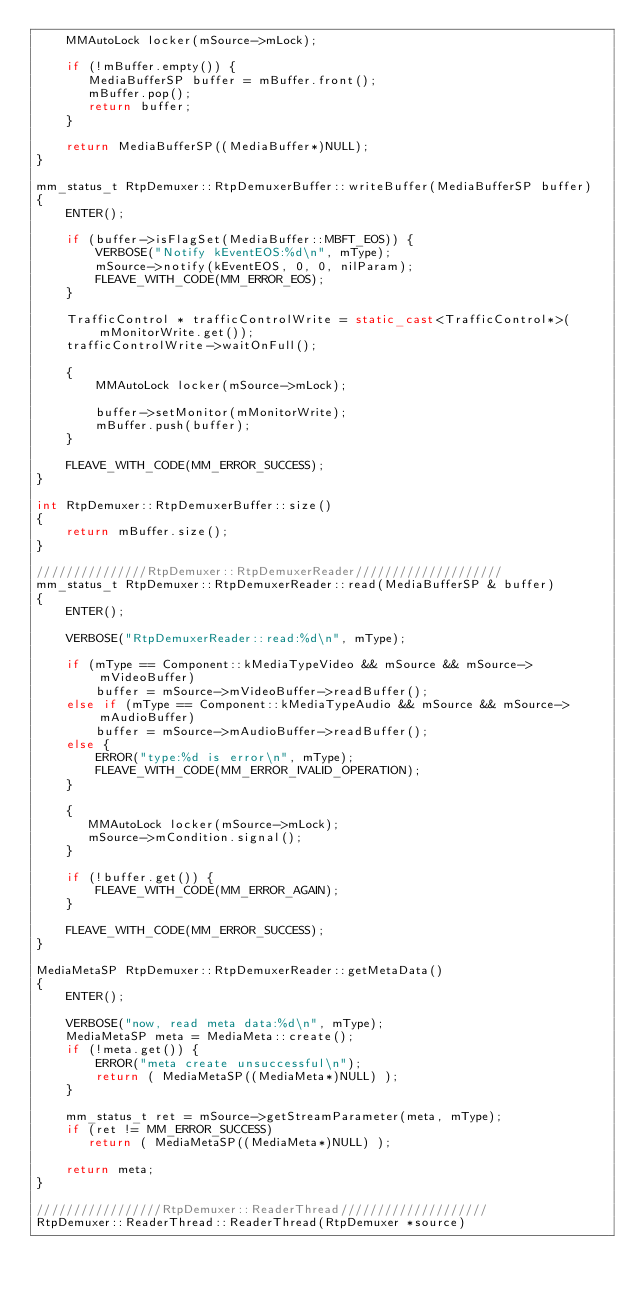<code> <loc_0><loc_0><loc_500><loc_500><_C++_>    MMAutoLock locker(mSource->mLock);

    if (!mBuffer.empty()) {
       MediaBufferSP buffer = mBuffer.front();
       mBuffer.pop();
       return buffer;
    }

    return MediaBufferSP((MediaBuffer*)NULL);
}

mm_status_t RtpDemuxer::RtpDemuxerBuffer::writeBuffer(MediaBufferSP buffer)
{
    ENTER();

    if (buffer->isFlagSet(MediaBuffer::MBFT_EOS)) {
        VERBOSE("Notify kEventEOS:%d\n", mType);
        mSource->notify(kEventEOS, 0, 0, nilParam);
        FLEAVE_WITH_CODE(MM_ERROR_EOS);
    }

    TrafficControl * trafficControlWrite = static_cast<TrafficControl*>(mMonitorWrite.get());
    trafficControlWrite->waitOnFull();

    {
        MMAutoLock locker(mSource->mLock);

        buffer->setMonitor(mMonitorWrite);
        mBuffer.push(buffer);
    }

    FLEAVE_WITH_CODE(MM_ERROR_SUCCESS);
}

int RtpDemuxer::RtpDemuxerBuffer::size()
{
    return mBuffer.size();
}

///////////////RtpDemuxer::RtpDemuxerReader////////////////////
mm_status_t RtpDemuxer::RtpDemuxerReader::read(MediaBufferSP & buffer)
{
    ENTER();

    VERBOSE("RtpDemuxerReader::read:%d\n", mType);

    if (mType == Component::kMediaTypeVideo && mSource && mSource->mVideoBuffer)
        buffer = mSource->mVideoBuffer->readBuffer();
    else if (mType == Component::kMediaTypeAudio && mSource && mSource->mAudioBuffer)
        buffer = mSource->mAudioBuffer->readBuffer();
    else {
        ERROR("type:%d is error\n", mType);
        FLEAVE_WITH_CODE(MM_ERROR_IVALID_OPERATION);
    }

    {
       MMAutoLock locker(mSource->mLock);
       mSource->mCondition.signal();
    }

    if (!buffer.get()) {
        FLEAVE_WITH_CODE(MM_ERROR_AGAIN);
    }

    FLEAVE_WITH_CODE(MM_ERROR_SUCCESS);
}

MediaMetaSP RtpDemuxer::RtpDemuxerReader::getMetaData()
{
    ENTER();

    VERBOSE("now, read meta data:%d\n", mType);
    MediaMetaSP meta = MediaMeta::create();
    if (!meta.get()) {
        ERROR("meta create unsuccessful\n");
        return ( MediaMetaSP((MediaMeta*)NULL) );
    }

    mm_status_t ret = mSource->getStreamParameter(meta, mType);
    if (ret != MM_ERROR_SUCCESS)
       return ( MediaMetaSP((MediaMeta*)NULL) );

    return meta;
}

/////////////////RtpDemuxer::ReaderThread////////////////////
RtpDemuxer::ReaderThread::ReaderThread(RtpDemuxer *source)</code> 